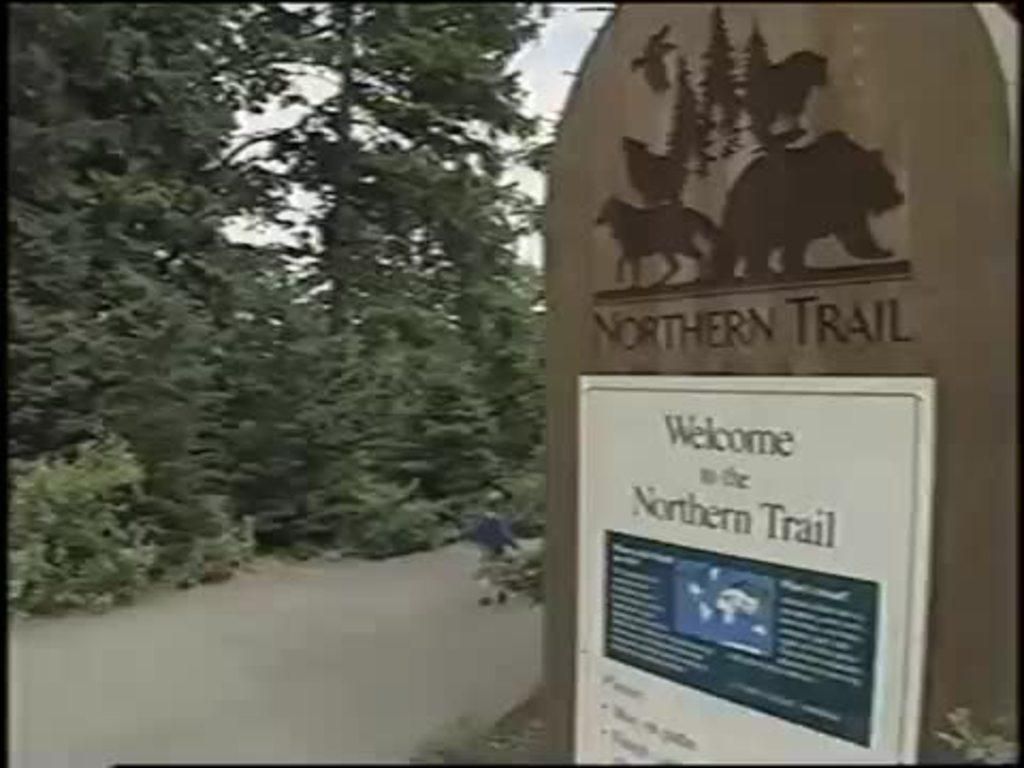<image>
Give a short and clear explanation of the subsequent image. A sign next to a path says Northern Trail. 